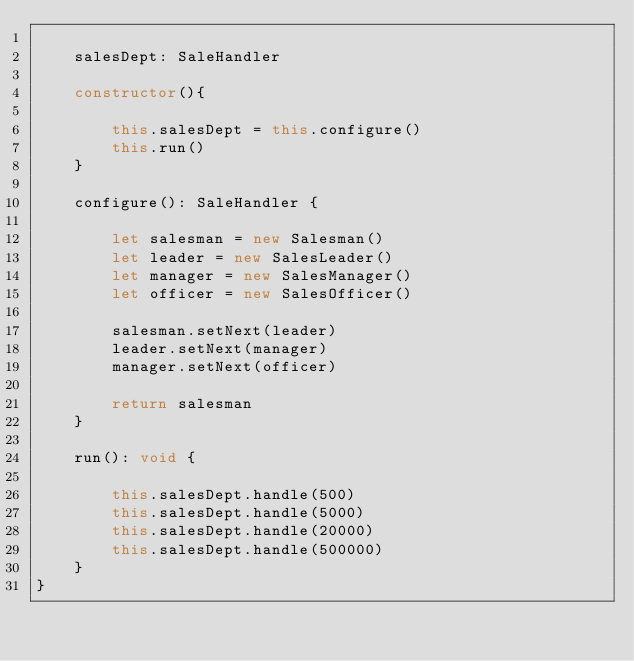Convert code to text. <code><loc_0><loc_0><loc_500><loc_500><_TypeScript_>
    salesDept: SaleHandler

    constructor(){

        this.salesDept = this.configure()
        this.run()
    }

    configure(): SaleHandler {
        
        let salesman = new Salesman()
        let leader = new SalesLeader()
        let manager = new SalesManager()
        let officer = new SalesOfficer()

        salesman.setNext(leader)
        leader.setNext(manager)
        manager.setNext(officer)

        return salesman
    }

    run(): void {

        this.salesDept.handle(500)
        this.salesDept.handle(5000)
        this.salesDept.handle(20000)
        this.salesDept.handle(500000)
    }
}</code> 